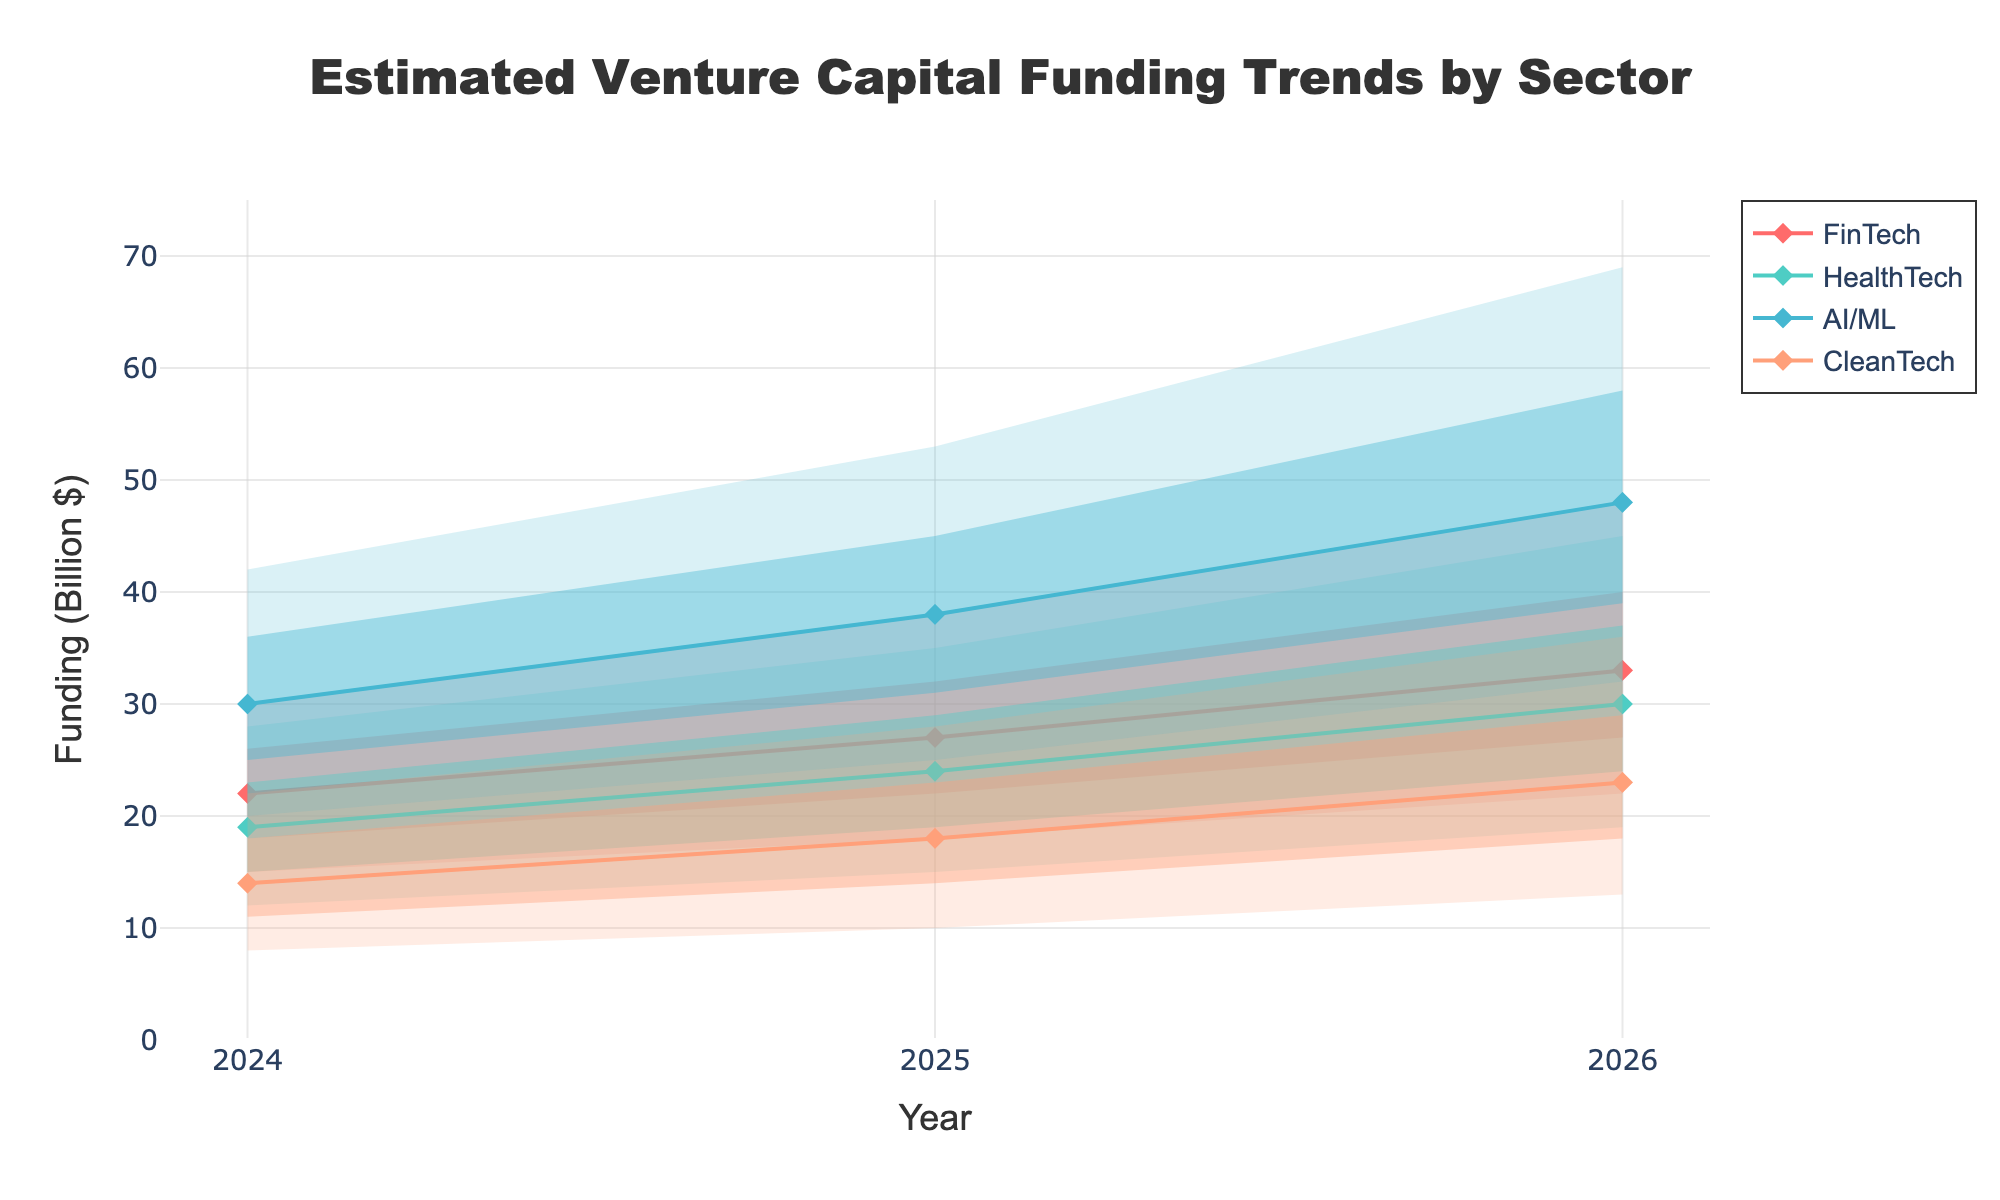What's the title of the chart? The title is located at the top center of the chart and is the main heading indicating what the chart is about. The title reads "Estimated Venture Capital Funding Trends by Sector".
Answer: Estimated Venture Capital Funding Trends by Sector Which sector is predicted to have the highest funding in 2026? To find the sector with the highest predicted funding in 2026, we look at the 'High Estimate' values for 2026 and compare them. The AI/ML sector has the highest value of 69 billion dollars.
Answer: AI/ML What is the range of funding estimates for CleanTech in 2025? The range can be determined by the difference between the 'High Estimate' and the 'Low Estimate' for CleanTech in 2025. The values are 28 and 10 billion dollars, respectively, so the range is 28 - 10 = 18 billion dollars.
Answer: 18 billion dollars How does the Mid Estimate for HealthTech change from 2024 to 2026? To find the change in the Mid Estimate for HealthTech, we subtract the Mid Estimate in 2024 from the Mid Estimate in 2026. The values are 30 billion dollars in 2026 and 19 billion dollars in 2024. So, 30 - 19 = 11 billion dollars.
Answer: 11 billion dollars Between HealthTech and CleanTech, which sector has a greater increase in High-Mid Estimate from 2024 to 2026? We compare the increase in High-Mid Estimates for both sectors over the specified period. For HealthTech, the increase is 37 - 23 = 14 billion dollars, while for CleanTech, it is 29 - 18 = 11 billion dollars. HealthTech has a greater increase.
Answer: HealthTech What is the average Mid Estimate for FinTech across the three years? To calculate the average Mid Estimate for FinTech from 2024 to 2026, sum the Mid Estimates for each year and divide by the number of years. The Mid Estimates are 22, 27, and 33 billion dollars. So, (22 + 27 + 33) / 3 = 82 / 3 ≈ 27.33 billion dollars.
Answer: 27.33 billion dollars Which sector shows the smallest Low Estimate in any year? By scanning the Low Estimates for all sectors across the years, CleanTech in 2024 has the smallest value at 8 billion dollars.
Answer: CleanTech What is the difference in the Low-Mid Estimate for AI/ML between 2025 and 2026? The Low-Mid Estimate for AI/ML in 2025 is 31 billion dollars and in 2026 it’s 39 billion dollars. The difference is 39 - 31 = 8 billion dollars.
Answer: 8 billion dollars 